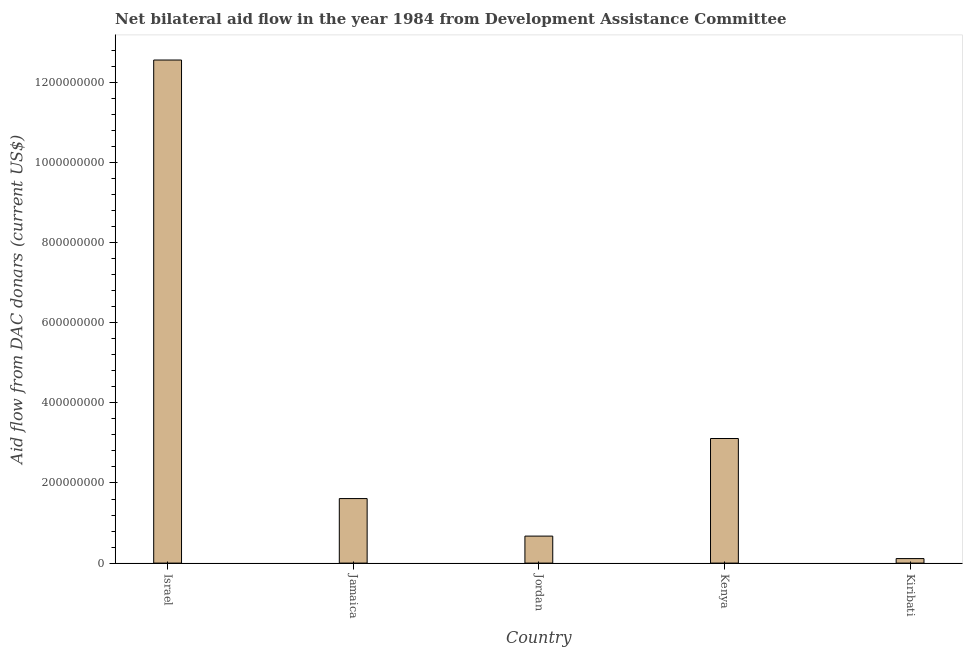What is the title of the graph?
Make the answer very short. Net bilateral aid flow in the year 1984 from Development Assistance Committee. What is the label or title of the X-axis?
Make the answer very short. Country. What is the label or title of the Y-axis?
Your answer should be compact. Aid flow from DAC donars (current US$). What is the net bilateral aid flows from dac donors in Israel?
Provide a succinct answer. 1.26e+09. Across all countries, what is the maximum net bilateral aid flows from dac donors?
Your response must be concise. 1.26e+09. Across all countries, what is the minimum net bilateral aid flows from dac donors?
Offer a very short reply. 1.13e+07. In which country was the net bilateral aid flows from dac donors minimum?
Give a very brief answer. Kiribati. What is the sum of the net bilateral aid flows from dac donors?
Give a very brief answer. 1.81e+09. What is the difference between the net bilateral aid flows from dac donors in Kenya and Kiribati?
Make the answer very short. 3.00e+08. What is the average net bilateral aid flows from dac donors per country?
Your answer should be compact. 3.61e+08. What is the median net bilateral aid flows from dac donors?
Offer a terse response. 1.61e+08. What is the ratio of the net bilateral aid flows from dac donors in Jamaica to that in Kenya?
Provide a succinct answer. 0.52. Is the difference between the net bilateral aid flows from dac donors in Israel and Kiribati greater than the difference between any two countries?
Your answer should be compact. Yes. What is the difference between the highest and the second highest net bilateral aid flows from dac donors?
Your answer should be compact. 9.45e+08. What is the difference between the highest and the lowest net bilateral aid flows from dac donors?
Ensure brevity in your answer.  1.24e+09. How many bars are there?
Make the answer very short. 5. How many countries are there in the graph?
Ensure brevity in your answer.  5. Are the values on the major ticks of Y-axis written in scientific E-notation?
Offer a very short reply. No. What is the Aid flow from DAC donars (current US$) of Israel?
Your answer should be compact. 1.26e+09. What is the Aid flow from DAC donars (current US$) in Jamaica?
Keep it short and to the point. 1.61e+08. What is the Aid flow from DAC donars (current US$) of Jordan?
Ensure brevity in your answer.  6.74e+07. What is the Aid flow from DAC donars (current US$) of Kenya?
Ensure brevity in your answer.  3.11e+08. What is the Aid flow from DAC donars (current US$) of Kiribati?
Your answer should be compact. 1.13e+07. What is the difference between the Aid flow from DAC donars (current US$) in Israel and Jamaica?
Offer a terse response. 1.09e+09. What is the difference between the Aid flow from DAC donars (current US$) in Israel and Jordan?
Your answer should be compact. 1.19e+09. What is the difference between the Aid flow from DAC donars (current US$) in Israel and Kenya?
Offer a terse response. 9.45e+08. What is the difference between the Aid flow from DAC donars (current US$) in Israel and Kiribati?
Keep it short and to the point. 1.24e+09. What is the difference between the Aid flow from DAC donars (current US$) in Jamaica and Jordan?
Your answer should be compact. 9.37e+07. What is the difference between the Aid flow from DAC donars (current US$) in Jamaica and Kenya?
Your answer should be very brief. -1.50e+08. What is the difference between the Aid flow from DAC donars (current US$) in Jamaica and Kiribati?
Your answer should be compact. 1.50e+08. What is the difference between the Aid flow from DAC donars (current US$) in Jordan and Kenya?
Your answer should be very brief. -2.44e+08. What is the difference between the Aid flow from DAC donars (current US$) in Jordan and Kiribati?
Your answer should be compact. 5.61e+07. What is the difference between the Aid flow from DAC donars (current US$) in Kenya and Kiribati?
Give a very brief answer. 3.00e+08. What is the ratio of the Aid flow from DAC donars (current US$) in Israel to that in Jamaica?
Ensure brevity in your answer.  7.8. What is the ratio of the Aid flow from DAC donars (current US$) in Israel to that in Jordan?
Provide a short and direct response. 18.63. What is the ratio of the Aid flow from DAC donars (current US$) in Israel to that in Kenya?
Your answer should be very brief. 4.04. What is the ratio of the Aid flow from DAC donars (current US$) in Israel to that in Kiribati?
Your answer should be very brief. 111.44. What is the ratio of the Aid flow from DAC donars (current US$) in Jamaica to that in Jordan?
Offer a very short reply. 2.39. What is the ratio of the Aid flow from DAC donars (current US$) in Jamaica to that in Kenya?
Your answer should be very brief. 0.52. What is the ratio of the Aid flow from DAC donars (current US$) in Jamaica to that in Kiribati?
Your answer should be very brief. 14.29. What is the ratio of the Aid flow from DAC donars (current US$) in Jordan to that in Kenya?
Keep it short and to the point. 0.22. What is the ratio of the Aid flow from DAC donars (current US$) in Jordan to that in Kiribati?
Keep it short and to the point. 5.98. What is the ratio of the Aid flow from DAC donars (current US$) in Kenya to that in Kiribati?
Ensure brevity in your answer.  27.6. 